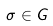<formula> <loc_0><loc_0><loc_500><loc_500>\sigma \in G</formula> 